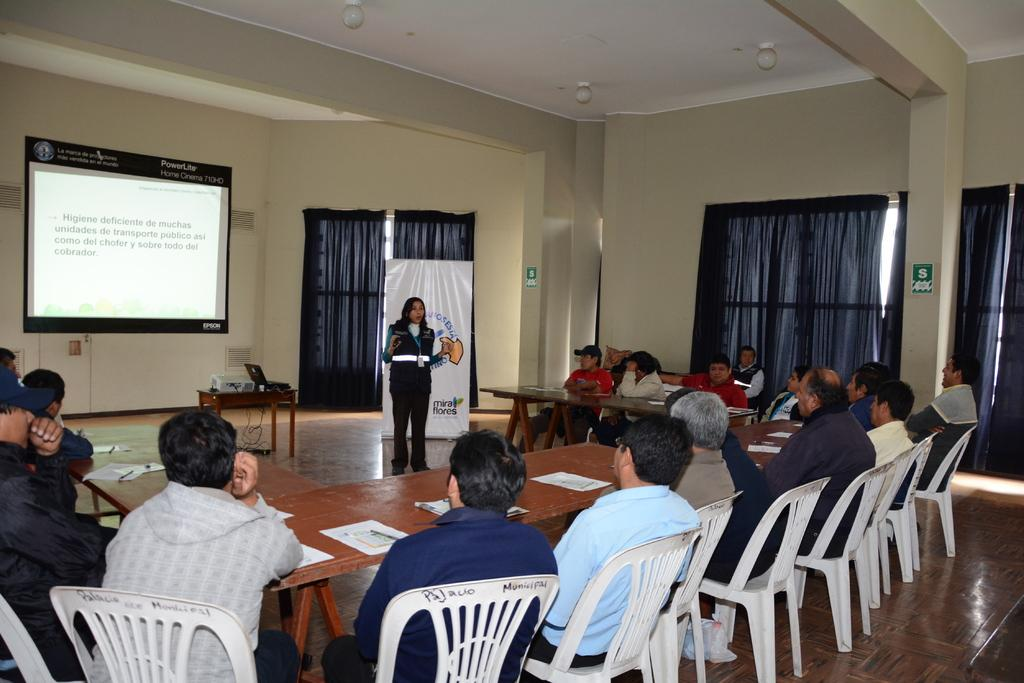What are the people in the image doing? The people in the image are sitting on chairs. Where are the people sitting in relation to the tables? The people are sitting in front of the tables. What is the lady in the image doing? The lady is standing in front of the people. What can be seen behind the people? There is a projector screen in the image. What type of pollution is visible in the image? There is no visible pollution in the image. What is the chance of rain during the event in the image? The image does not provide any information about the weather or the possibility of rain. 